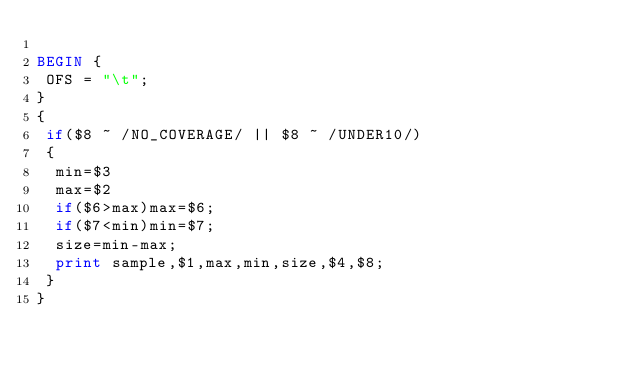<code> <loc_0><loc_0><loc_500><loc_500><_Awk_>
BEGIN {
 OFS = "\t";
}
{
 if($8 ~ /NO_COVERAGE/ || $8 ~ /UNDER10/)
 {
  min=$3
  max=$2
  if($6>max)max=$6;
  if($7<min)min=$7;
  size=min-max;
  print sample,$1,max,min,size,$4,$8;
 }
}

</code> 